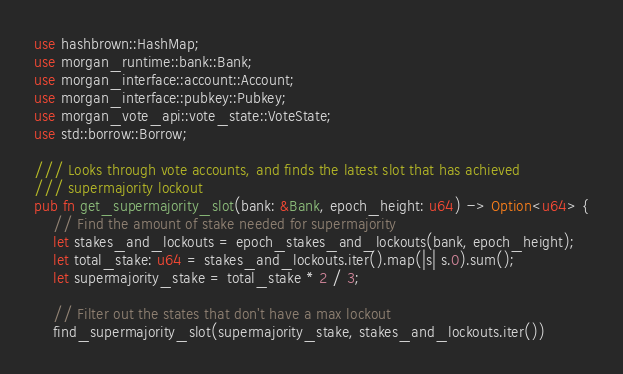<code> <loc_0><loc_0><loc_500><loc_500><_Rust_>use hashbrown::HashMap;
use morgan_runtime::bank::Bank;
use morgan_interface::account::Account;
use morgan_interface::pubkey::Pubkey;
use morgan_vote_api::vote_state::VoteState;
use std::borrow::Borrow;

/// Looks through vote accounts, and finds the latest slot that has achieved
/// supermajority lockout
pub fn get_supermajority_slot(bank: &Bank, epoch_height: u64) -> Option<u64> {
    // Find the amount of stake needed for supermajority
    let stakes_and_lockouts = epoch_stakes_and_lockouts(bank, epoch_height);
    let total_stake: u64 = stakes_and_lockouts.iter().map(|s| s.0).sum();
    let supermajority_stake = total_stake * 2 / 3;

    // Filter out the states that don't have a max lockout
    find_supermajority_slot(supermajority_stake, stakes_and_lockouts.iter())</code> 